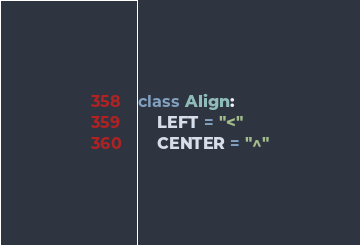<code> <loc_0><loc_0><loc_500><loc_500><_Python_>class Align:
    LEFT = "<"
    CENTER = "^"
</code> 